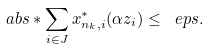<formula> <loc_0><loc_0><loc_500><loc_500>\ a b s * { \sum _ { i \in J } x _ { n _ { k } , i } ^ { * } ( \alpha z _ { i } ) } \leq \ e p s .</formula> 